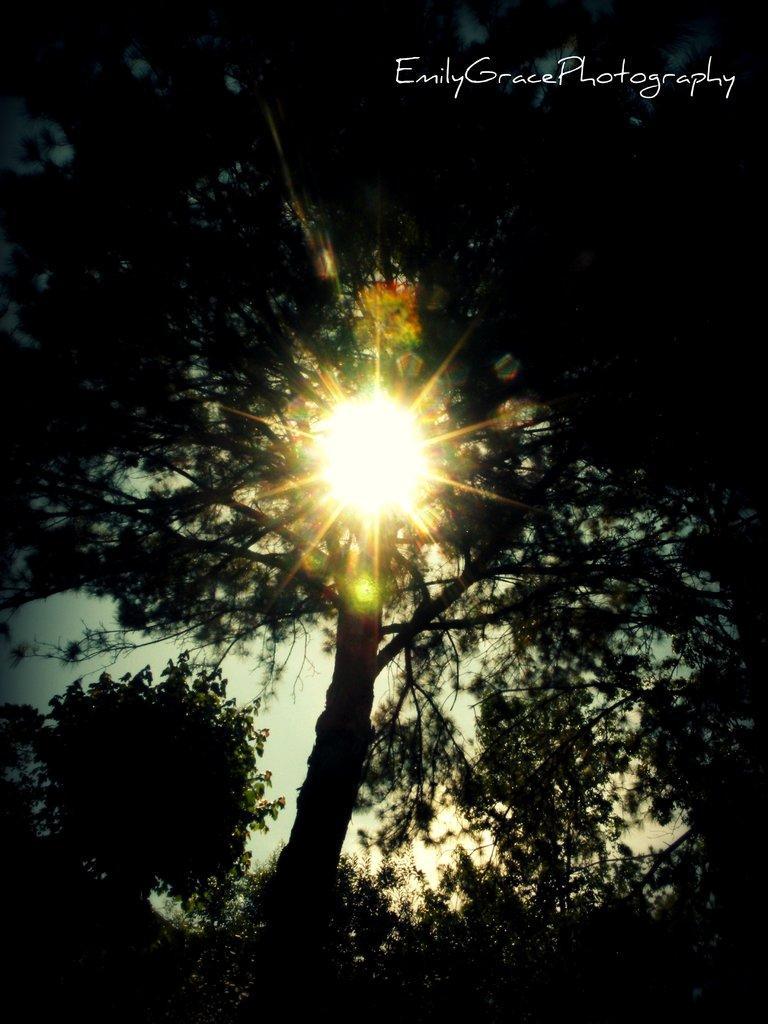Describe this image in one or two sentences. In this image I can see trees. There is sunlight and there is sky in the background. 